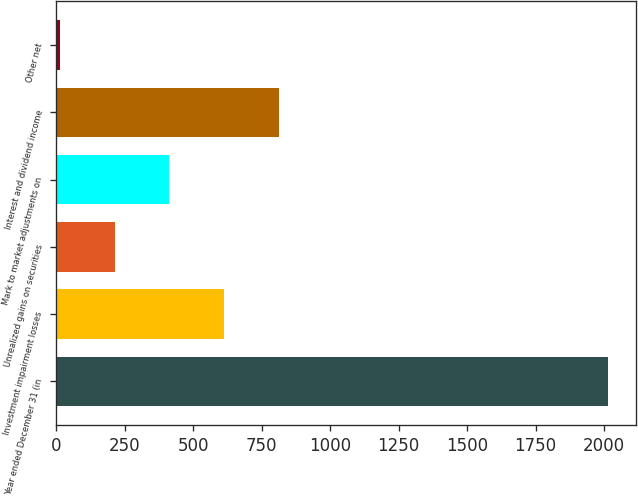Convert chart to OTSL. <chart><loc_0><loc_0><loc_500><loc_500><bar_chart><fcel>Year ended December 31 (in<fcel>Investment impairment losses<fcel>Unrealized gains on securities<fcel>Mark to market adjustments on<fcel>Interest and dividend income<fcel>Other net<nl><fcel>2015<fcel>613.6<fcel>213.2<fcel>413.4<fcel>813.8<fcel>13<nl></chart> 